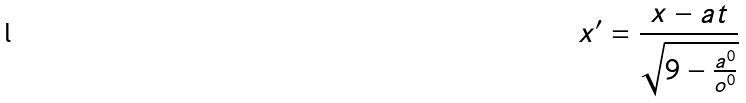Convert formula to latex. <formula><loc_0><loc_0><loc_500><loc_500>x ^ { \prime } = \frac { x - a t } { \sqrt { 9 - \frac { a ^ { 0 } } { o ^ { 0 } } } }</formula> 